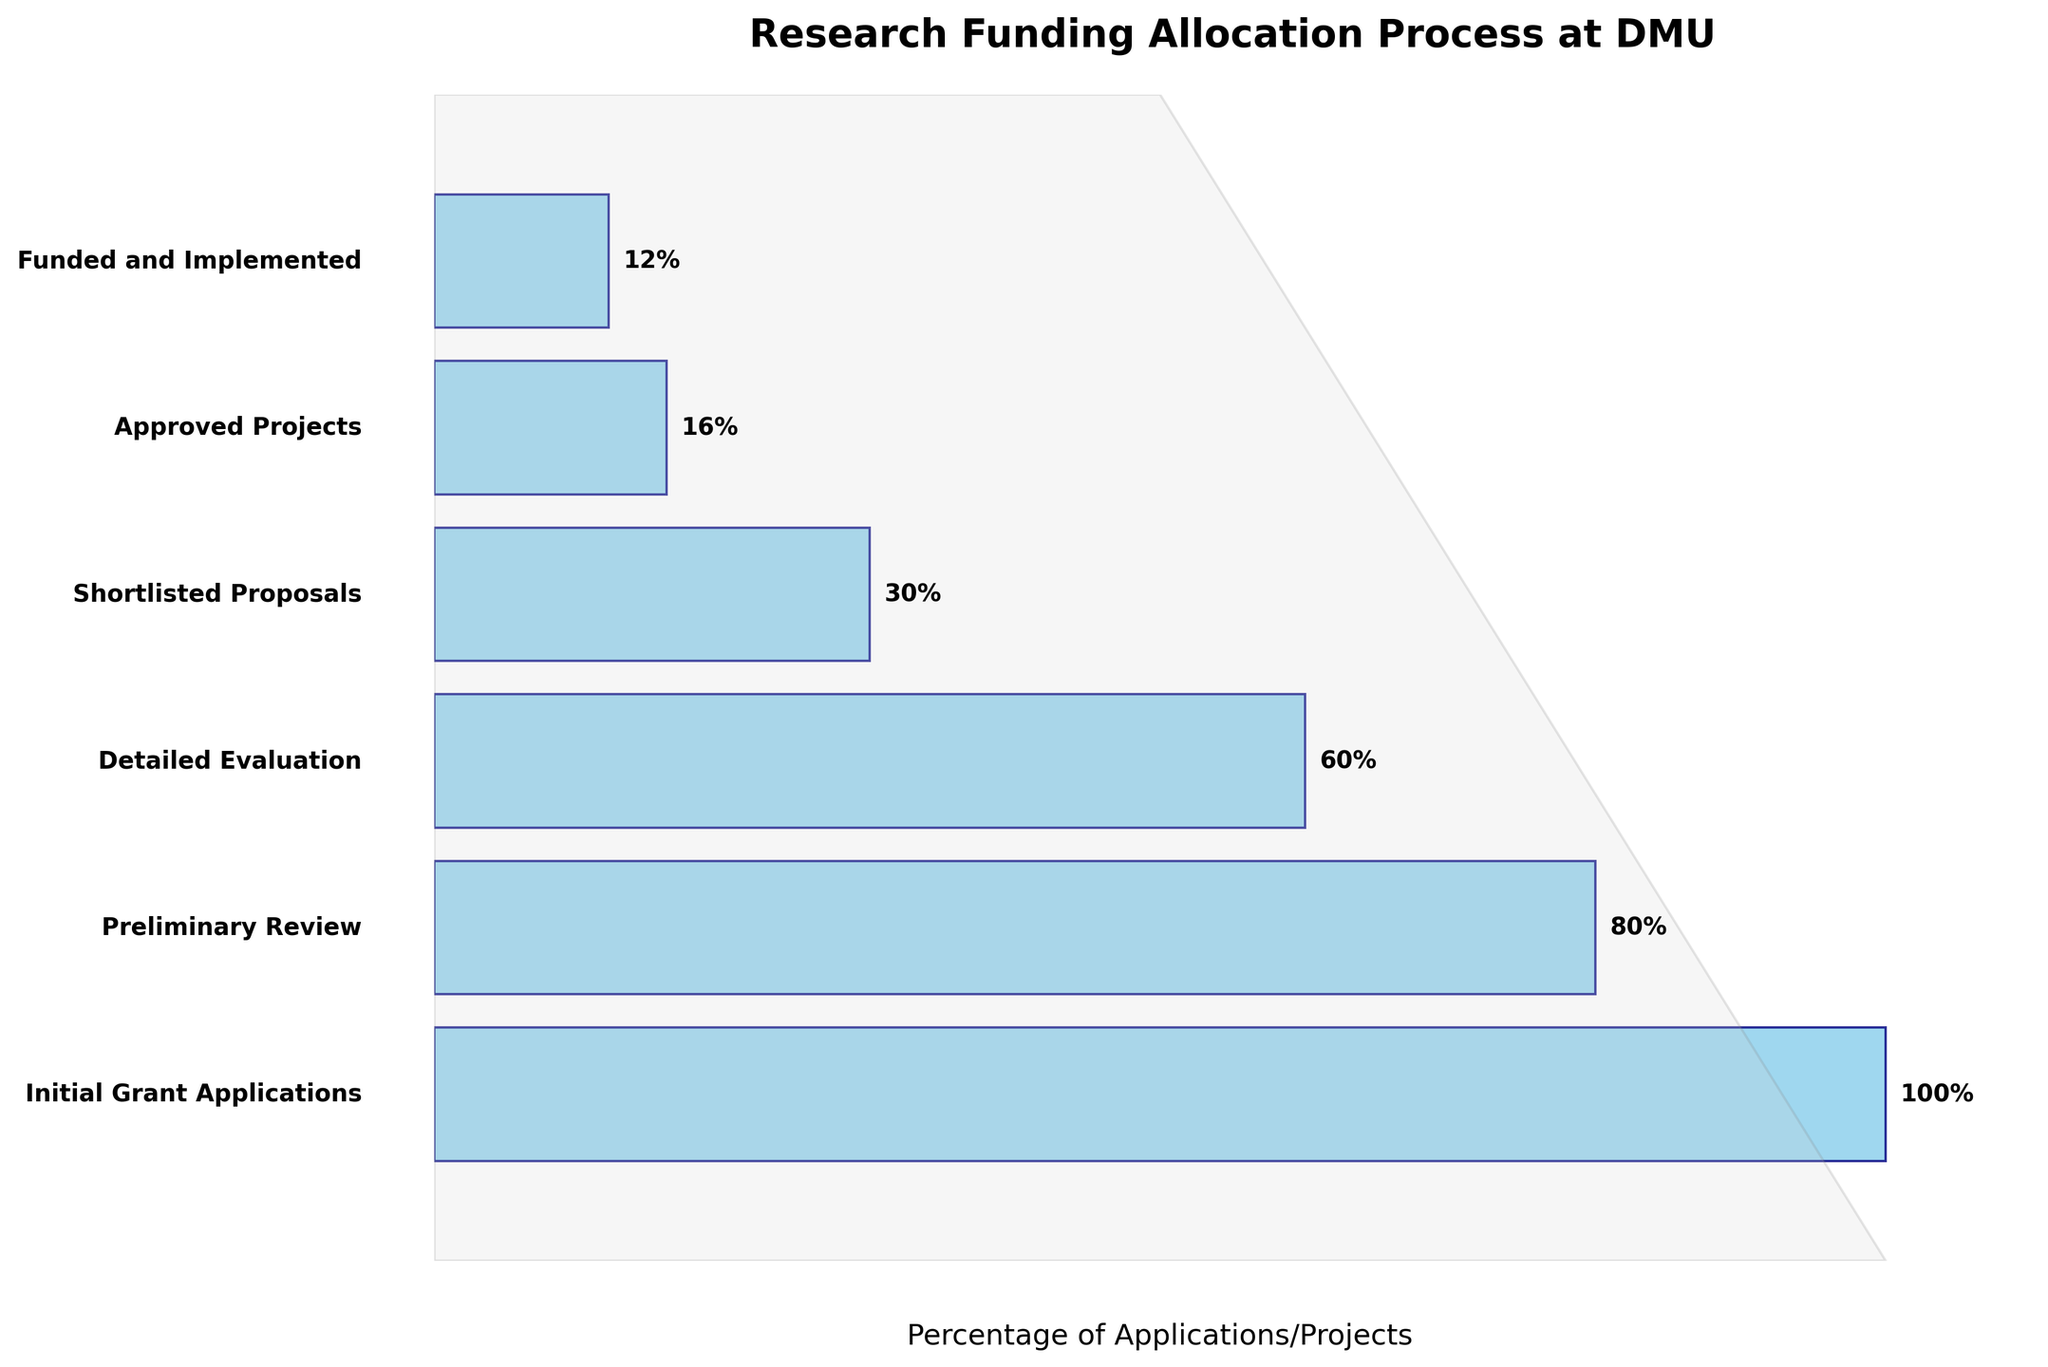What is the title of the figure? The title is typically found at the top of the figure and is meant to provide a brief description of the content. In this case, it says "Research Funding Allocation Process at DMU".
Answer: Research Funding Allocation Process at DMU How many stages are represented in the figure? By counting the number of distinct stages listed on the y-axis, we can determine that there are six stages shown.
Answer: Six Which stage has the highest percentage of applications? The stage with the highest percentage is typically the first one in a funnel chart, as each subsequent stage filters out more applications. The first stage here, "Initial Grant Applications," has 100%.
Answer: Initial Grant Applications What percentage of applications reach the "Shortlisted Proposals" stage? Looking at the data point for the "Shortlisted Proposals" stage on the y-axis and following the corresponding bar to the x-axis, the percentage is 30%.
Answer: 30% How many projects are funded and implemented? The final stage in the funnel chart is "Funded and Implemented," which has 30 projects, as noted in the data.
Answer: 30 What is the dropout percentage between "Initial Grant Applications" and "Preliminary Review"? Subtract the percentage of "Preliminary Review" (80%) from "Initial Grant Applications" (100%) to find the dropout percentage.
Answer: 20% How does the number of applications in the "Approved Projects" stage compare to those in the "Shortlisted Proposals" stage? The number of "Approved Projects" is 40, and the number for "Shortlisted Proposals" is 75. Subtracting 40 from 75 shows there are 35 more applications at the "Shortlisted Proposals" stage.
Answer: There are 35 more applications at the "Shortlisted Proposals" stage What is the percentage decrease from the "Detailed Evaluation" stage to the "Funded and Implemented" stage? The percentage at "Detailed Evaluation" is 60%, and at "Funded and Implemented," it's 12%. The decrease is calculated as 60% - 12% = 48%.
Answer: 48% How many stages exist between the "Preliminary Review" and the "Approved Projects"? By counting the stages listed between "Preliminary Review" and "Approved Projects" on the y-axis, there are two stages: "Detailed Evaluation" and "Shortlisted Proposals."
Answer: Two If 80% of initial applications make it to the "Preliminary Review" stage, how many applications is this? 80% of the initial 250 applications equals 0.8 * 250, which equals 200 applications at the "Preliminary Review" stage.
Answer: 200 